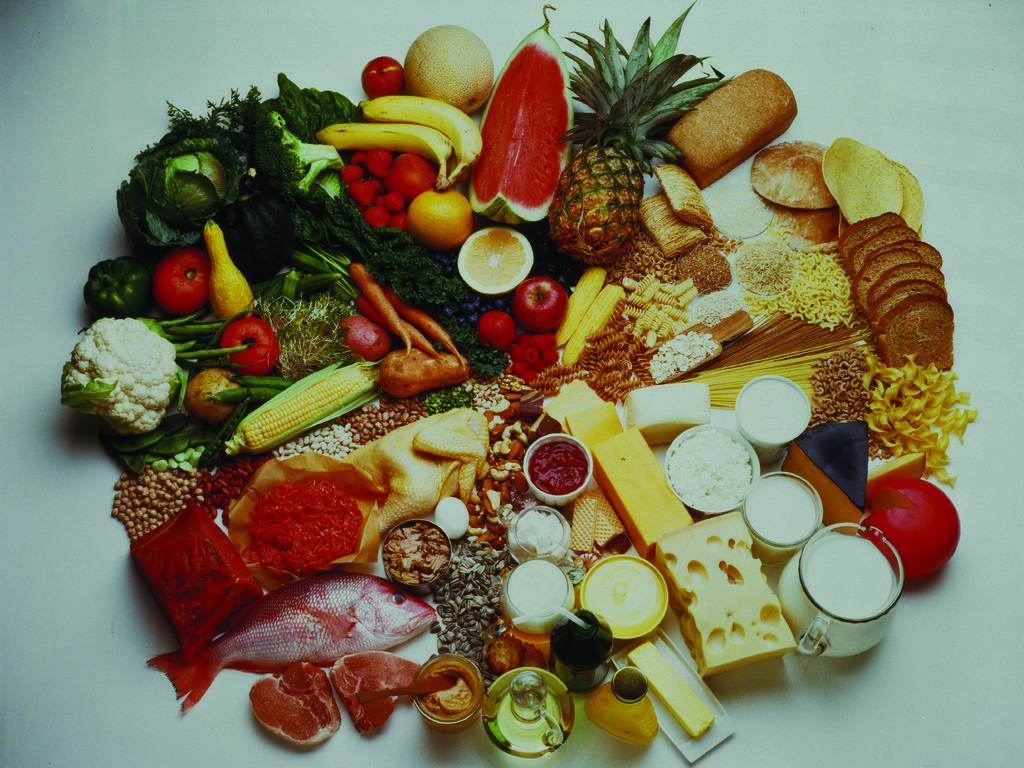How would you summarize this image in a sentence or two? In this picture, we can see some food items kept on the white surface. 